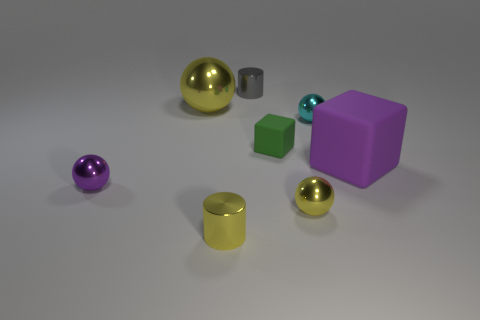Add 2 tiny matte cylinders. How many objects exist? 10 Subtract all cubes. How many objects are left? 6 Add 5 cyan balls. How many cyan balls exist? 6 Subtract 0 cyan blocks. How many objects are left? 8 Subtract all tiny rubber objects. Subtract all small yellow metallic spheres. How many objects are left? 6 Add 8 rubber things. How many rubber things are left? 10 